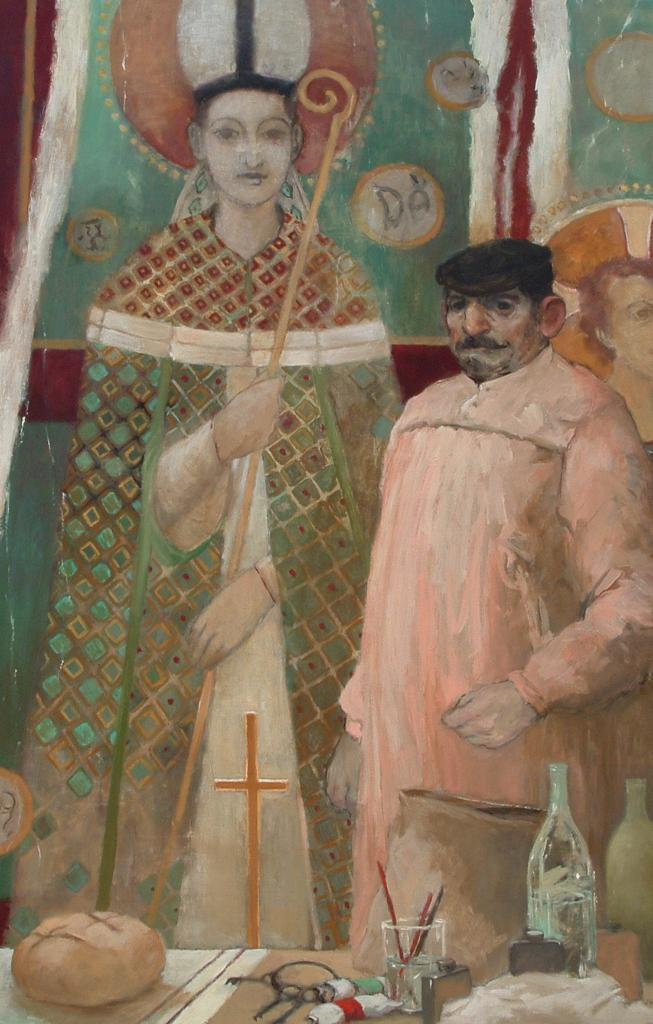What is depicted in the foreground of the image? There are paintings of two people and a table in the foreground of the image. What is on the table in the image? Glass and bottles are on the table in the image. Are there any other objects on the table? Yes, there are additional objects on the table. Can you tell me how many airports are visible in the image? There are no airports present in the image. What type of bread is being served on the table in the image? There is no bread visible in the image. 